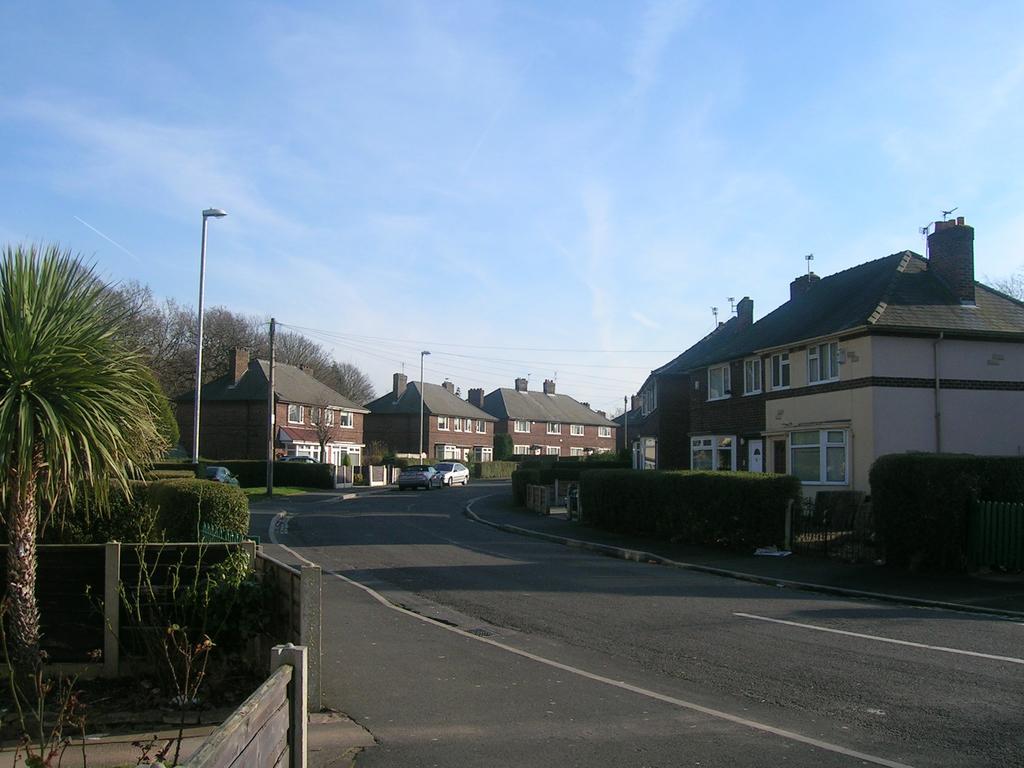Can you describe this image briefly? In the center of the image we can see two vehicles on the road. In the background we can see the sky,clouds,trees,plants,fences,poles,buildings,windows and a few other objects. 